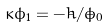<formula> <loc_0><loc_0><loc_500><loc_500>\kappa \phi _ { 1 } = - \dot { h } / \dot { \phi } _ { 0 }</formula> 